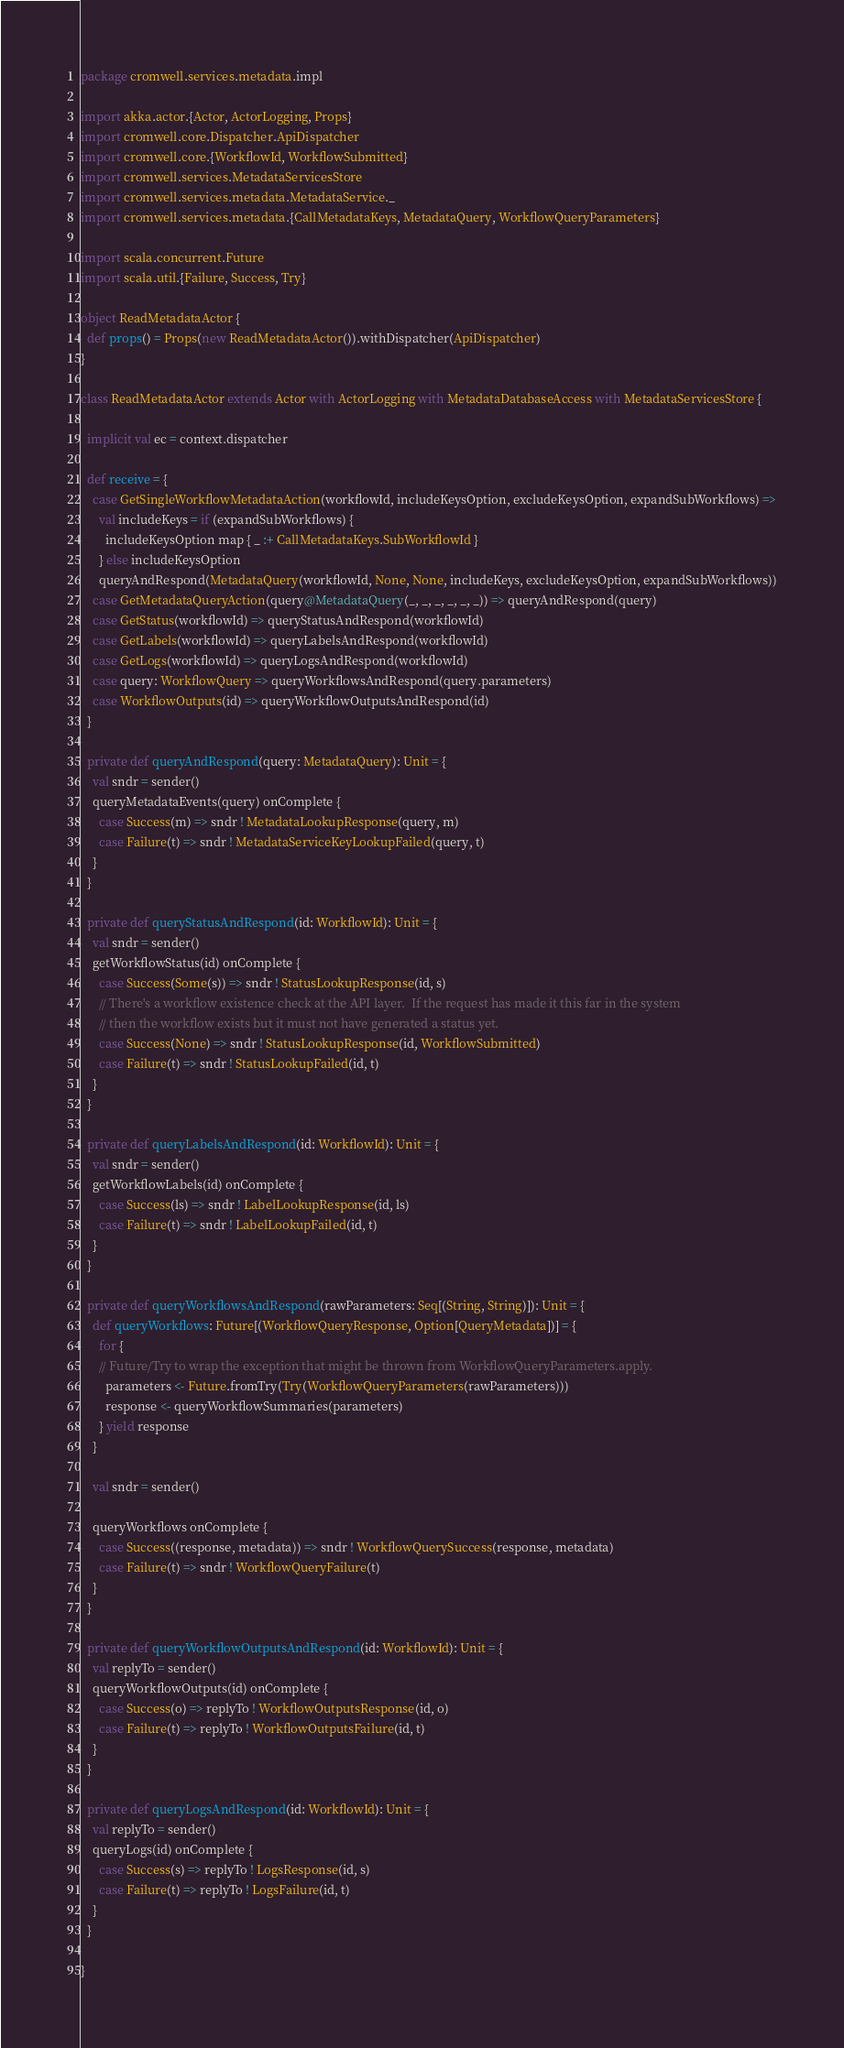<code> <loc_0><loc_0><loc_500><loc_500><_Scala_>package cromwell.services.metadata.impl

import akka.actor.{Actor, ActorLogging, Props}
import cromwell.core.Dispatcher.ApiDispatcher
import cromwell.core.{WorkflowId, WorkflowSubmitted}
import cromwell.services.MetadataServicesStore
import cromwell.services.metadata.MetadataService._
import cromwell.services.metadata.{CallMetadataKeys, MetadataQuery, WorkflowQueryParameters}

import scala.concurrent.Future
import scala.util.{Failure, Success, Try}

object ReadMetadataActor {
  def props() = Props(new ReadMetadataActor()).withDispatcher(ApiDispatcher)
}

class ReadMetadataActor extends Actor with ActorLogging with MetadataDatabaseAccess with MetadataServicesStore {

  implicit val ec = context.dispatcher

  def receive = {
    case GetSingleWorkflowMetadataAction(workflowId, includeKeysOption, excludeKeysOption, expandSubWorkflows) =>
      val includeKeys = if (expandSubWorkflows) {
        includeKeysOption map { _ :+ CallMetadataKeys.SubWorkflowId }
      } else includeKeysOption
      queryAndRespond(MetadataQuery(workflowId, None, None, includeKeys, excludeKeysOption, expandSubWorkflows))
    case GetMetadataQueryAction(query@MetadataQuery(_, _, _, _, _, _)) => queryAndRespond(query)
    case GetStatus(workflowId) => queryStatusAndRespond(workflowId)
    case GetLabels(workflowId) => queryLabelsAndRespond(workflowId)
    case GetLogs(workflowId) => queryLogsAndRespond(workflowId)
    case query: WorkflowQuery => queryWorkflowsAndRespond(query.parameters)
    case WorkflowOutputs(id) => queryWorkflowOutputsAndRespond(id)
  }

  private def queryAndRespond(query: MetadataQuery): Unit = {
    val sndr = sender()
    queryMetadataEvents(query) onComplete {
      case Success(m) => sndr ! MetadataLookupResponse(query, m)
      case Failure(t) => sndr ! MetadataServiceKeyLookupFailed(query, t)
    }
  }

  private def queryStatusAndRespond(id: WorkflowId): Unit = {
    val sndr = sender()
    getWorkflowStatus(id) onComplete {
      case Success(Some(s)) => sndr ! StatusLookupResponse(id, s)
      // There's a workflow existence check at the API layer.  If the request has made it this far in the system
      // then the workflow exists but it must not have generated a status yet.
      case Success(None) => sndr ! StatusLookupResponse(id, WorkflowSubmitted)
      case Failure(t) => sndr ! StatusLookupFailed(id, t)
    }
  }

  private def queryLabelsAndRespond(id: WorkflowId): Unit = {
    val sndr = sender()
    getWorkflowLabels(id) onComplete {
      case Success(ls) => sndr ! LabelLookupResponse(id, ls)
      case Failure(t) => sndr ! LabelLookupFailed(id, t)
    }
  }

  private def queryWorkflowsAndRespond(rawParameters: Seq[(String, String)]): Unit = {
    def queryWorkflows: Future[(WorkflowQueryResponse, Option[QueryMetadata])] = {
      for {
      // Future/Try to wrap the exception that might be thrown from WorkflowQueryParameters.apply.
        parameters <- Future.fromTry(Try(WorkflowQueryParameters(rawParameters)))
        response <- queryWorkflowSummaries(parameters)
      } yield response
    }

    val sndr = sender()

    queryWorkflows onComplete {
      case Success((response, metadata)) => sndr ! WorkflowQuerySuccess(response, metadata)
      case Failure(t) => sndr ! WorkflowQueryFailure(t)
    }
  }

  private def queryWorkflowOutputsAndRespond(id: WorkflowId): Unit = {
    val replyTo = sender()
    queryWorkflowOutputs(id) onComplete {
      case Success(o) => replyTo ! WorkflowOutputsResponse(id, o)
      case Failure(t) => replyTo ! WorkflowOutputsFailure(id, t)
    }
  }

  private def queryLogsAndRespond(id: WorkflowId): Unit = {
    val replyTo = sender()
    queryLogs(id) onComplete {
      case Success(s) => replyTo ! LogsResponse(id, s)
      case Failure(t) => replyTo ! LogsFailure(id, t)
    }
  }

}
</code> 